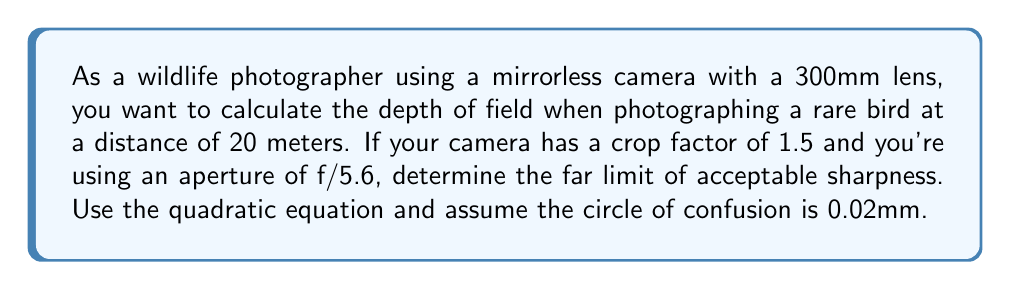Provide a solution to this math problem. To solve this problem, we'll use the depth of field equation and the quadratic formula:

1) The depth of field equation for the far limit is:
   $$ \frac{1}{x} = \frac{1}{s} - \frac{fc}{N(s-f)} $$
   where $x$ is the far limit, $s$ is the subject distance, $f$ is the focal length, $c$ is the circle of confusion, and $N$ is the f-number.

2) Given:
   $s = 20$ m
   $f = 300 \text{ mm} \times 1.5 = 450 \text{ mm} = 0.45 \text{ m}$
   $c = 0.02 \text{ mm} = 0.00002 \text{ m}$
   $N = 5.6$

3) Substitute these values into the equation:
   $$ \frac{1}{x} = \frac{1}{20} - \frac{0.45 \times 0.00002}{5.6(20-0.45)} $$

4) Simplify:
   $$ \frac{1}{x} = 0.05 - \frac{0.0000009}{5.6 \times 19.55} = 0.05 - 0.0000000082 $$

5) Rearrange to standard quadratic form:
   $$ 0.0499999918x - 1 = 0 $$

6) Solve using the quadratic formula $x = \frac{-b \pm \sqrt{b^2 - 4ac}}{2a}$:
   $$ x = \frac{1}{\0.0499999918} = 20.00000328 \text{ m} $$

7) Round to a reasonable number of significant figures:
   $x \approx 20.00 \text{ m}$
Answer: 20.00 m 